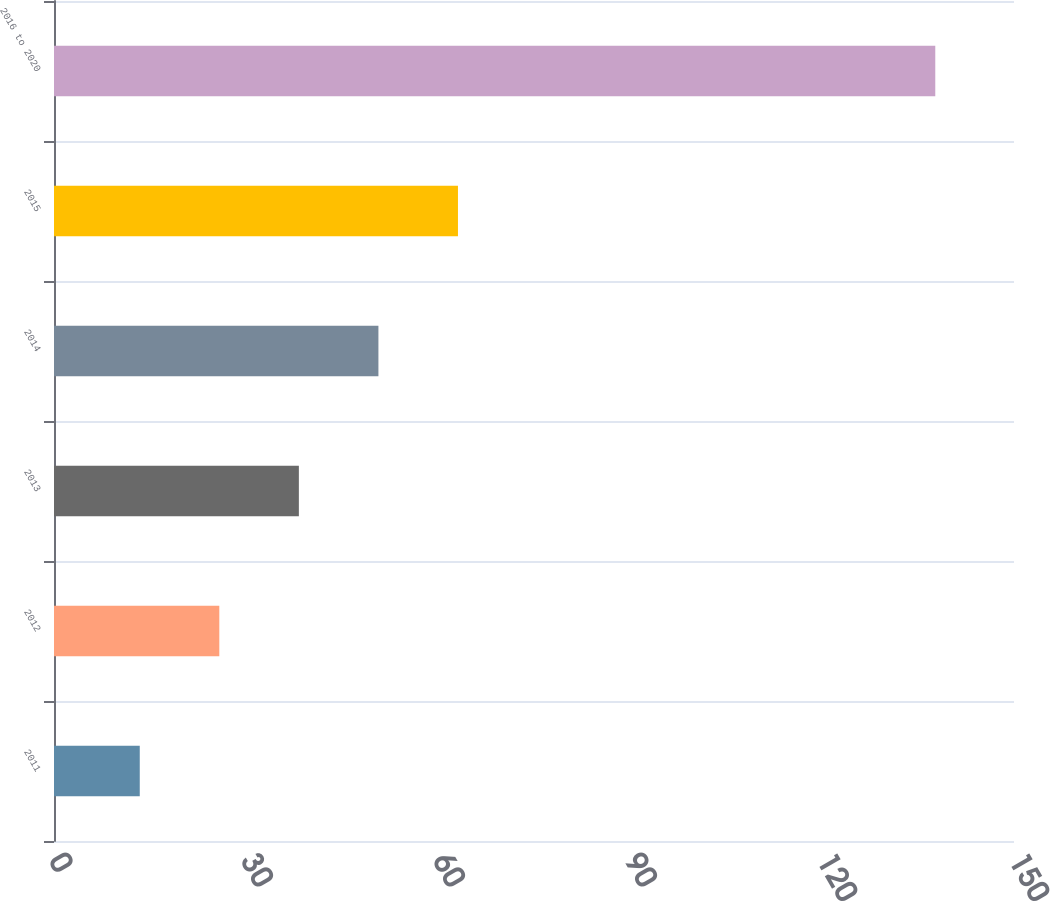<chart> <loc_0><loc_0><loc_500><loc_500><bar_chart><fcel>2011<fcel>2012<fcel>2013<fcel>2014<fcel>2015<fcel>2016 to 2020<nl><fcel>13.4<fcel>25.83<fcel>38.26<fcel>50.69<fcel>63.12<fcel>137.7<nl></chart> 